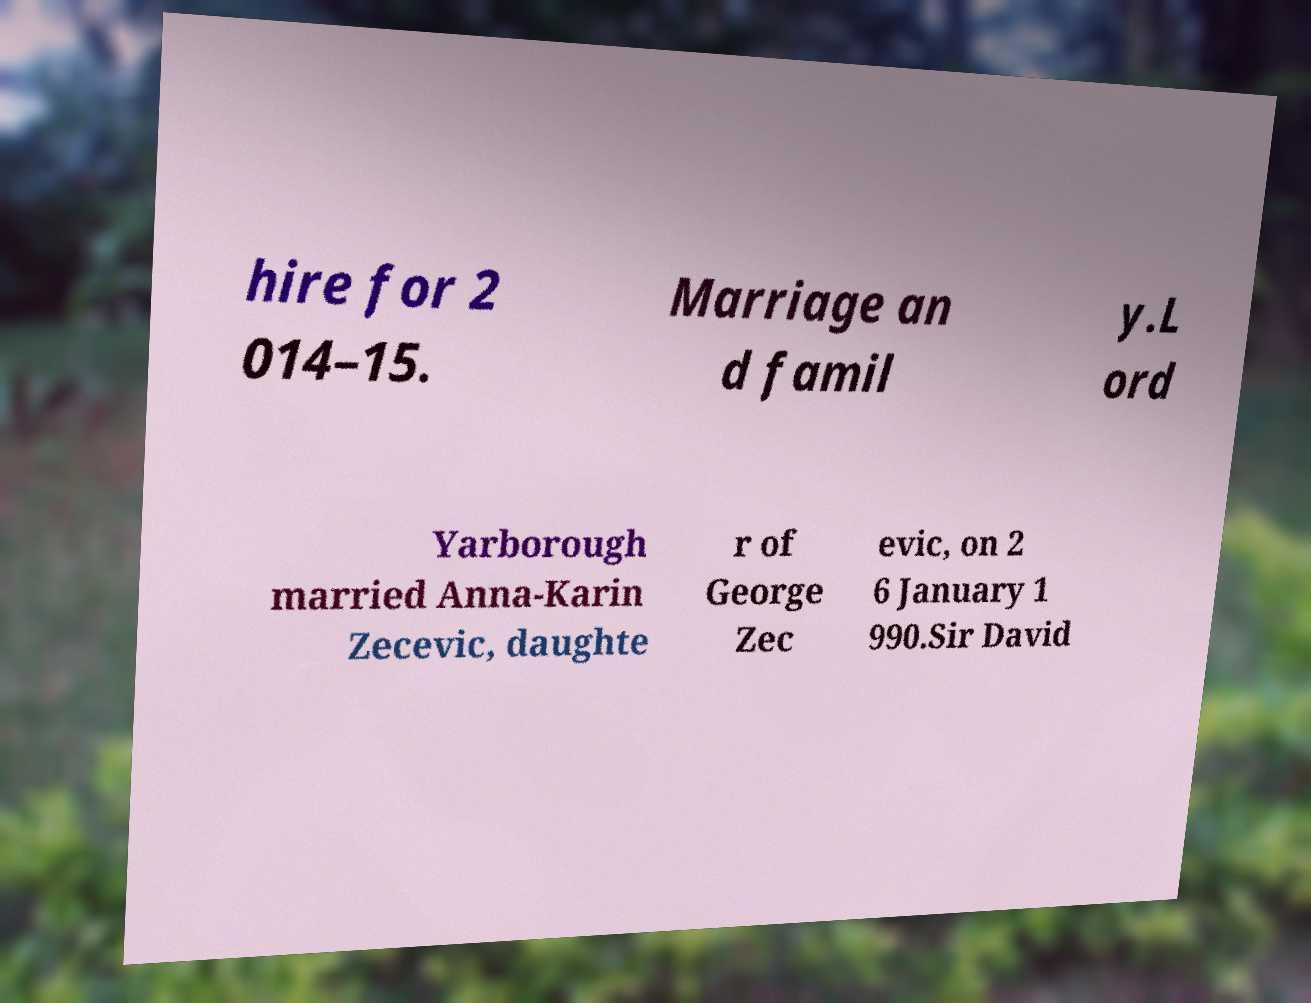I need the written content from this picture converted into text. Can you do that? hire for 2 014–15. Marriage an d famil y.L ord Yarborough married Anna-Karin Zecevic, daughte r of George Zec evic, on 2 6 January 1 990.Sir David 